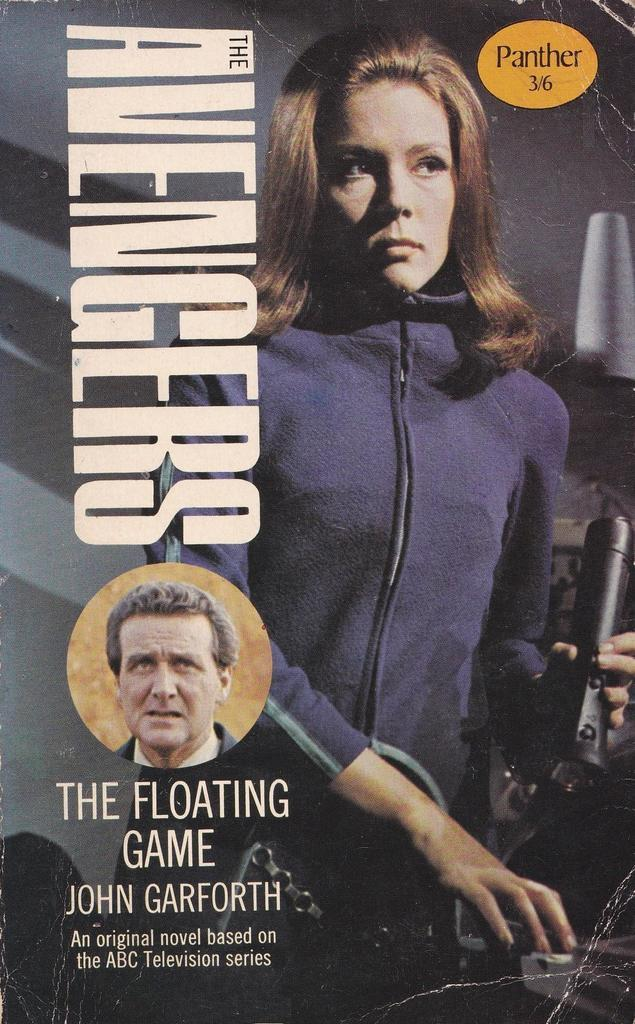What is featured on the poster in the image? There is a poster in the image, and it has a person on it. What else can be seen on the poster besides the person? There is text written on the poster. What is the person in the poster holding? The person in the poster is holding a black color object. What is the size of the locket worn by the person in the poster? There is no locket visible in the image; the person in the poster is holding a black color object. 